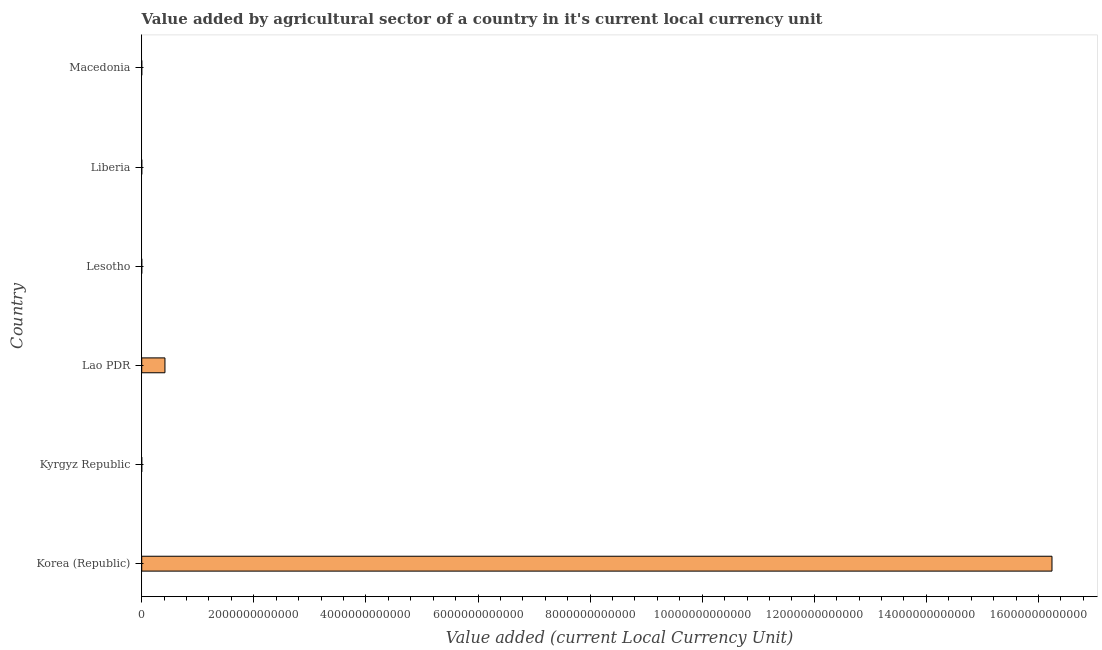Does the graph contain any zero values?
Ensure brevity in your answer.  No. What is the title of the graph?
Ensure brevity in your answer.  Value added by agricultural sector of a country in it's current local currency unit. What is the label or title of the X-axis?
Give a very brief answer. Value added (current Local Currency Unit). What is the label or title of the Y-axis?
Your answer should be compact. Country. What is the value added by agriculture sector in Korea (Republic)?
Offer a very short reply. 1.62e+13. Across all countries, what is the maximum value added by agriculture sector?
Provide a short and direct response. 1.62e+13. Across all countries, what is the minimum value added by agriculture sector?
Offer a terse response. 3.26e+07. In which country was the value added by agriculture sector maximum?
Your answer should be compact. Korea (Republic). In which country was the value added by agriculture sector minimum?
Keep it short and to the point. Kyrgyz Republic. What is the sum of the value added by agriculture sector?
Your response must be concise. 1.67e+13. What is the difference between the value added by agriculture sector in Lao PDR and Lesotho?
Your answer should be very brief. 4.14e+11. What is the average value added by agriculture sector per country?
Your answer should be very brief. 2.78e+12. What is the median value added by agriculture sector?
Your response must be concise. 2.31e+08. In how many countries, is the value added by agriculture sector greater than 9600000000000 LCU?
Provide a succinct answer. 1. What is the ratio of the value added by agriculture sector in Korea (Republic) to that in Kyrgyz Republic?
Give a very brief answer. 4.98e+05. Is the difference between the value added by agriculture sector in Lesotho and Macedonia greater than the difference between any two countries?
Your answer should be very brief. No. What is the difference between the highest and the second highest value added by agriculture sector?
Ensure brevity in your answer.  1.58e+13. Is the sum of the value added by agriculture sector in Lao PDR and Liberia greater than the maximum value added by agriculture sector across all countries?
Offer a very short reply. No. What is the difference between the highest and the lowest value added by agriculture sector?
Provide a short and direct response. 1.62e+13. How many bars are there?
Your response must be concise. 6. Are all the bars in the graph horizontal?
Provide a succinct answer. Yes. What is the difference between two consecutive major ticks on the X-axis?
Offer a very short reply. 2.00e+12. What is the Value added (current Local Currency Unit) of Korea (Republic)?
Ensure brevity in your answer.  1.62e+13. What is the Value added (current Local Currency Unit) in Kyrgyz Republic?
Give a very brief answer. 3.26e+07. What is the Value added (current Local Currency Unit) of Lao PDR?
Provide a short and direct response. 4.14e+11. What is the Value added (current Local Currency Unit) in Lesotho?
Give a very brief answer. 2.69e+08. What is the Value added (current Local Currency Unit) of Liberia?
Your response must be concise. 1.94e+08. What is the Value added (current Local Currency Unit) in Macedonia?
Keep it short and to the point. 1.05e+08. What is the difference between the Value added (current Local Currency Unit) in Korea (Republic) and Kyrgyz Republic?
Give a very brief answer. 1.62e+13. What is the difference between the Value added (current Local Currency Unit) in Korea (Republic) and Lao PDR?
Ensure brevity in your answer.  1.58e+13. What is the difference between the Value added (current Local Currency Unit) in Korea (Republic) and Lesotho?
Your answer should be compact. 1.62e+13. What is the difference between the Value added (current Local Currency Unit) in Korea (Republic) and Liberia?
Make the answer very short. 1.62e+13. What is the difference between the Value added (current Local Currency Unit) in Korea (Republic) and Macedonia?
Provide a short and direct response. 1.62e+13. What is the difference between the Value added (current Local Currency Unit) in Kyrgyz Republic and Lao PDR?
Your response must be concise. -4.14e+11. What is the difference between the Value added (current Local Currency Unit) in Kyrgyz Republic and Lesotho?
Offer a very short reply. -2.37e+08. What is the difference between the Value added (current Local Currency Unit) in Kyrgyz Republic and Liberia?
Provide a succinct answer. -1.61e+08. What is the difference between the Value added (current Local Currency Unit) in Kyrgyz Republic and Macedonia?
Ensure brevity in your answer.  -7.23e+07. What is the difference between the Value added (current Local Currency Unit) in Lao PDR and Lesotho?
Your answer should be very brief. 4.14e+11. What is the difference between the Value added (current Local Currency Unit) in Lao PDR and Liberia?
Provide a short and direct response. 4.14e+11. What is the difference between the Value added (current Local Currency Unit) in Lao PDR and Macedonia?
Make the answer very short. 4.14e+11. What is the difference between the Value added (current Local Currency Unit) in Lesotho and Liberia?
Offer a terse response. 7.58e+07. What is the difference between the Value added (current Local Currency Unit) in Lesotho and Macedonia?
Provide a short and direct response. 1.64e+08. What is the difference between the Value added (current Local Currency Unit) in Liberia and Macedonia?
Your answer should be very brief. 8.85e+07. What is the ratio of the Value added (current Local Currency Unit) in Korea (Republic) to that in Kyrgyz Republic?
Provide a short and direct response. 4.98e+05. What is the ratio of the Value added (current Local Currency Unit) in Korea (Republic) to that in Lao PDR?
Offer a very short reply. 39.18. What is the ratio of the Value added (current Local Currency Unit) in Korea (Republic) to that in Lesotho?
Ensure brevity in your answer.  6.03e+04. What is the ratio of the Value added (current Local Currency Unit) in Korea (Republic) to that in Liberia?
Your answer should be very brief. 8.39e+04. What is the ratio of the Value added (current Local Currency Unit) in Korea (Republic) to that in Macedonia?
Your response must be concise. 1.55e+05. What is the ratio of the Value added (current Local Currency Unit) in Kyrgyz Republic to that in Lao PDR?
Offer a terse response. 0. What is the ratio of the Value added (current Local Currency Unit) in Kyrgyz Republic to that in Lesotho?
Keep it short and to the point. 0.12. What is the ratio of the Value added (current Local Currency Unit) in Kyrgyz Republic to that in Liberia?
Provide a short and direct response. 0.17. What is the ratio of the Value added (current Local Currency Unit) in Kyrgyz Republic to that in Macedonia?
Ensure brevity in your answer.  0.31. What is the ratio of the Value added (current Local Currency Unit) in Lao PDR to that in Lesotho?
Your answer should be compact. 1539.18. What is the ratio of the Value added (current Local Currency Unit) in Lao PDR to that in Liberia?
Your answer should be very brief. 2142.12. What is the ratio of the Value added (current Local Currency Unit) in Lao PDR to that in Macedonia?
Keep it short and to the point. 3949.12. What is the ratio of the Value added (current Local Currency Unit) in Lesotho to that in Liberia?
Make the answer very short. 1.39. What is the ratio of the Value added (current Local Currency Unit) in Lesotho to that in Macedonia?
Provide a short and direct response. 2.57. What is the ratio of the Value added (current Local Currency Unit) in Liberia to that in Macedonia?
Offer a very short reply. 1.84. 